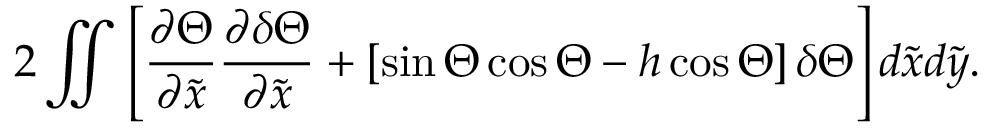<formula> <loc_0><loc_0><loc_500><loc_500>2 \iint \left [ \frac { \partial \Theta } { \partial \tilde { x } } \frac { \partial \delta \Theta } { \partial \tilde { x } } + \left [ \sin \Theta \cos \Theta - h \cos \Theta \right ] \delta \Theta \right ] d \tilde { x } d \tilde { y } .</formula> 